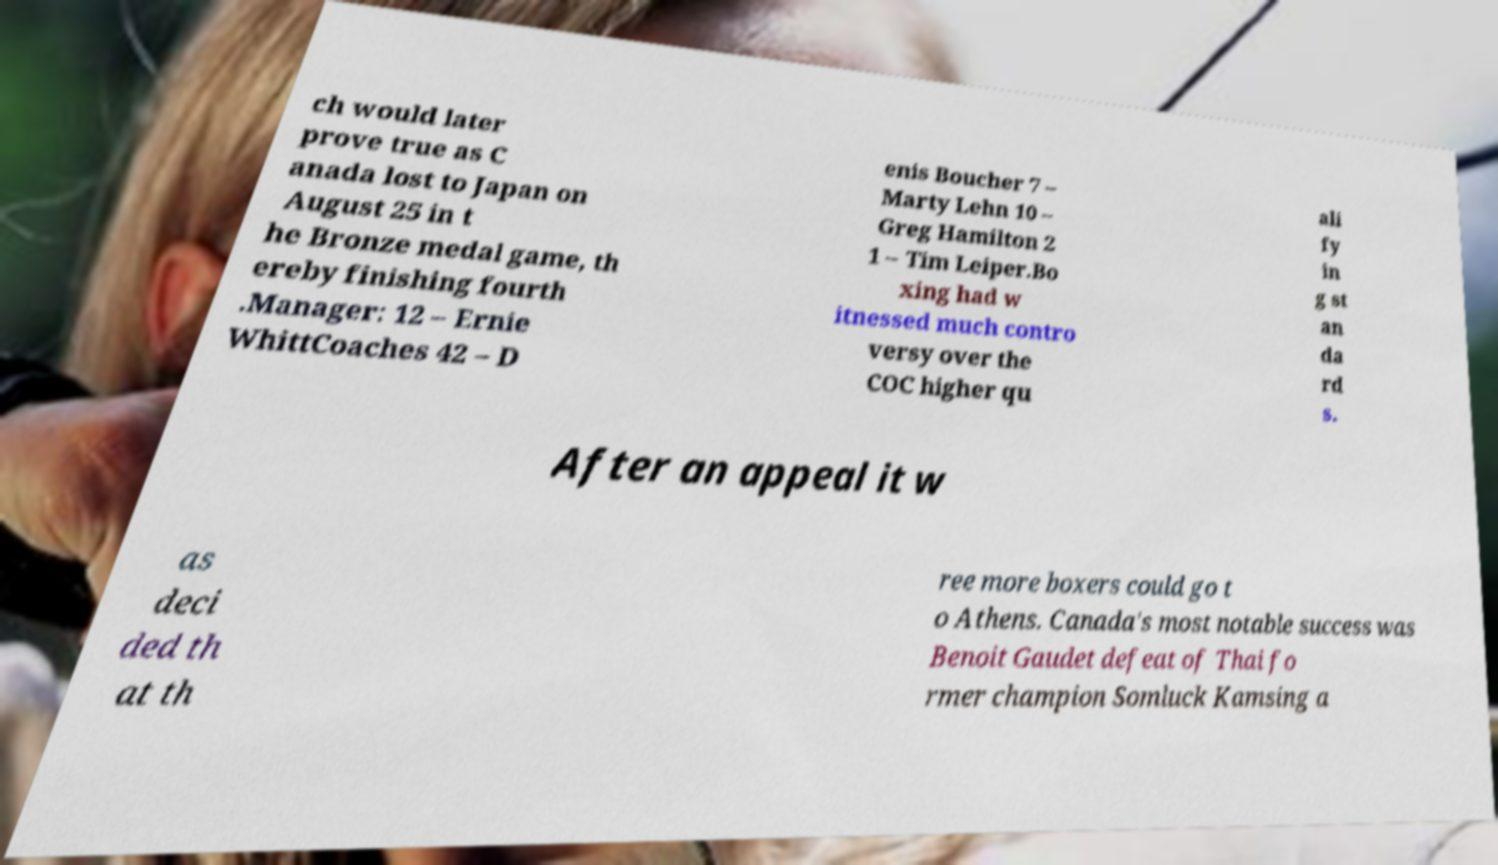Please identify and transcribe the text found in this image. ch would later prove true as C anada lost to Japan on August 25 in t he Bronze medal game, th ereby finishing fourth .Manager: 12 – Ernie WhittCoaches 42 – D enis Boucher 7 – Marty Lehn 10 – Greg Hamilton 2 1 – Tim Leiper.Bo xing had w itnessed much contro versy over the COC higher qu ali fy in g st an da rd s. After an appeal it w as deci ded th at th ree more boxers could go t o Athens. Canada's most notable success was Benoit Gaudet defeat of Thai fo rmer champion Somluck Kamsing a 